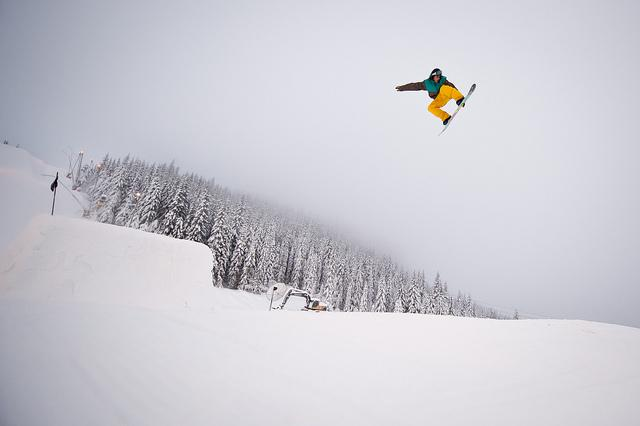How skilled is this skier in the activity? expert 